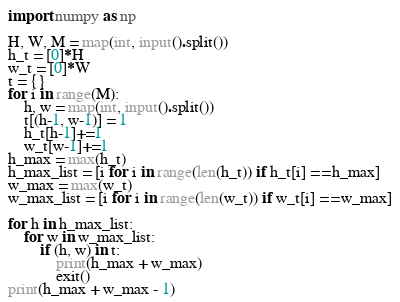<code> <loc_0><loc_0><loc_500><loc_500><_Python_>import numpy as np

H, W, M = map(int, input().split())
h_t = [0]*H
w_t = [0]*W
t = {}
for i in range(M):
    h, w = map(int, input().split())
    t[(h-1, w-1)] = 1
    h_t[h-1]+=1
    w_t[w-1]+=1
h_max = max(h_t)
h_max_list = [i for i in range(len(h_t)) if h_t[i] == h_max]
w_max = max(w_t)
w_max_list = [i for i in range(len(w_t)) if w_t[i] == w_max]

for h in h_max_list:
    for w in w_max_list:
        if (h, w) in t:
            print(h_max + w_max)
            exit()
print(h_max + w_max - 1)</code> 